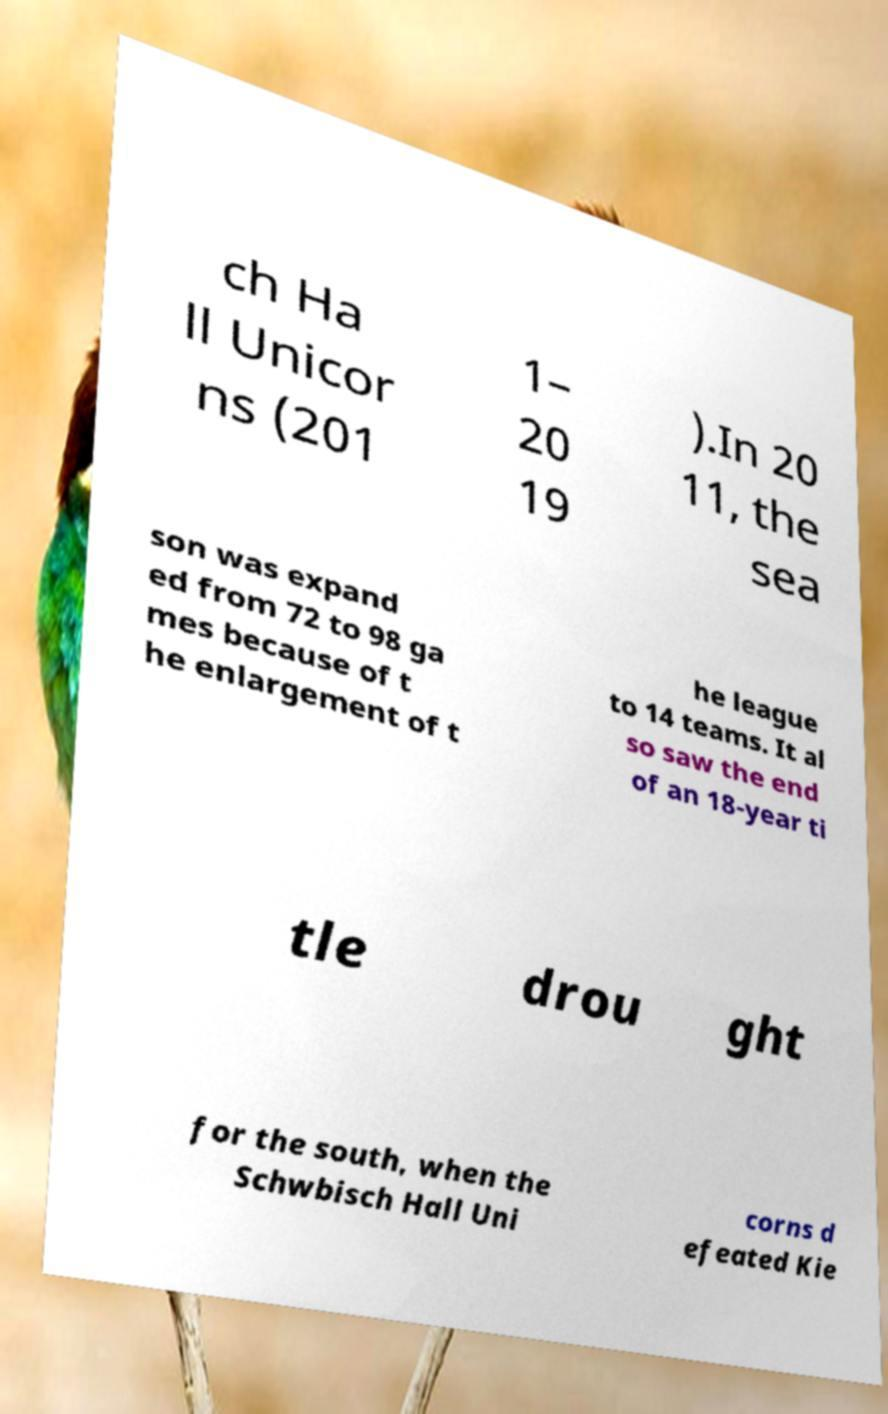Please identify and transcribe the text found in this image. ch Ha ll Unicor ns (201 1– 20 19 ).In 20 11, the sea son was expand ed from 72 to 98 ga mes because of t he enlargement of t he league to 14 teams. It al so saw the end of an 18-year ti tle drou ght for the south, when the Schwbisch Hall Uni corns d efeated Kie 